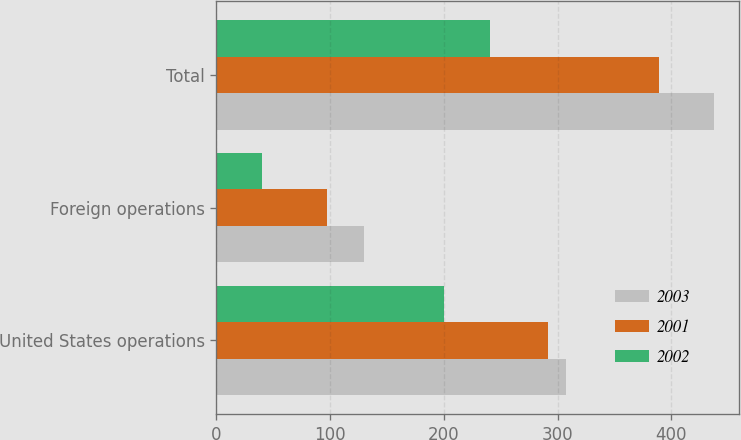<chart> <loc_0><loc_0><loc_500><loc_500><stacked_bar_chart><ecel><fcel>United States operations<fcel>Foreign operations<fcel>Total<nl><fcel>2003<fcel>307.6<fcel>129.9<fcel>437.5<nl><fcel>2001<fcel>292<fcel>96.9<fcel>388.9<nl><fcel>2002<fcel>200.4<fcel>40.5<fcel>240.9<nl></chart> 